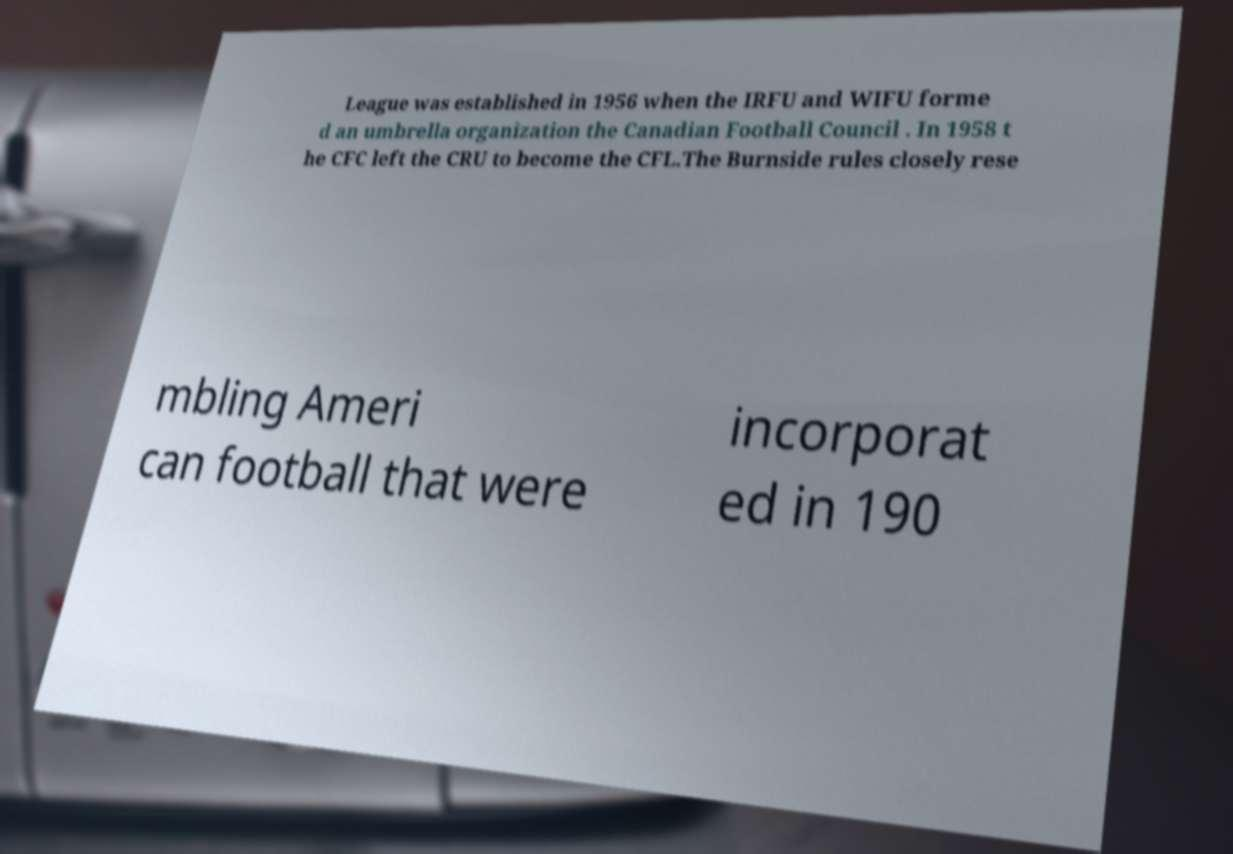I need the written content from this picture converted into text. Can you do that? League was established in 1956 when the IRFU and WIFU forme d an umbrella organization the Canadian Football Council . In 1958 t he CFC left the CRU to become the CFL.The Burnside rules closely rese mbling Ameri can football that were incorporat ed in 190 